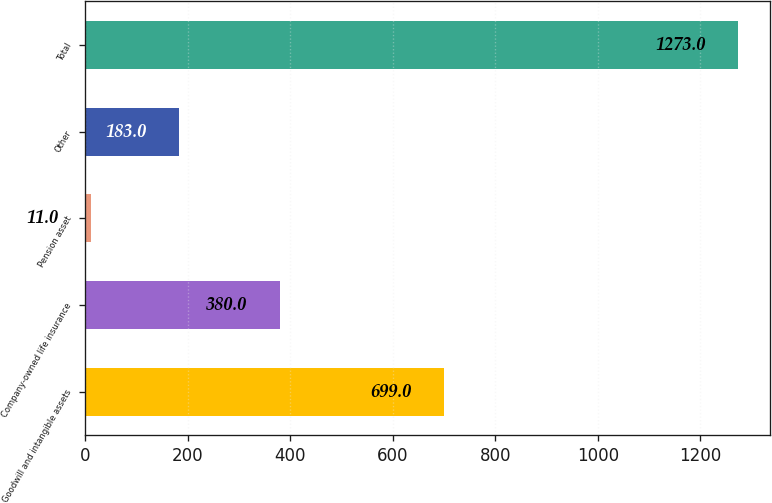Convert chart to OTSL. <chart><loc_0><loc_0><loc_500><loc_500><bar_chart><fcel>Goodwill and intangible assets<fcel>Company-owned life insurance<fcel>Pension asset<fcel>Other<fcel>Total<nl><fcel>699<fcel>380<fcel>11<fcel>183<fcel>1273<nl></chart> 